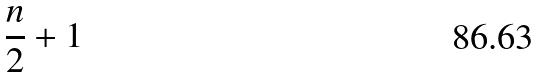Convert formula to latex. <formula><loc_0><loc_0><loc_500><loc_500>\frac { n } { 2 } + 1</formula> 